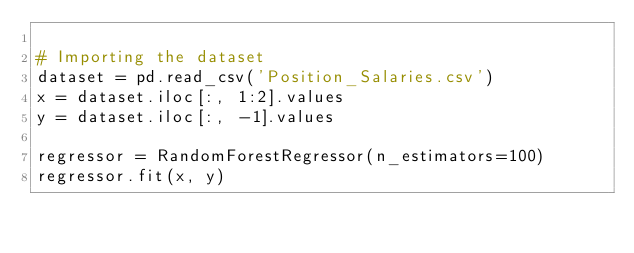<code> <loc_0><loc_0><loc_500><loc_500><_Python_>
# Importing the dataset
dataset = pd.read_csv('Position_Salaries.csv')
x = dataset.iloc[:, 1:2].values
y = dataset.iloc[:, -1].values

regressor = RandomForestRegressor(n_estimators=100)
regressor.fit(x, y)
</code> 